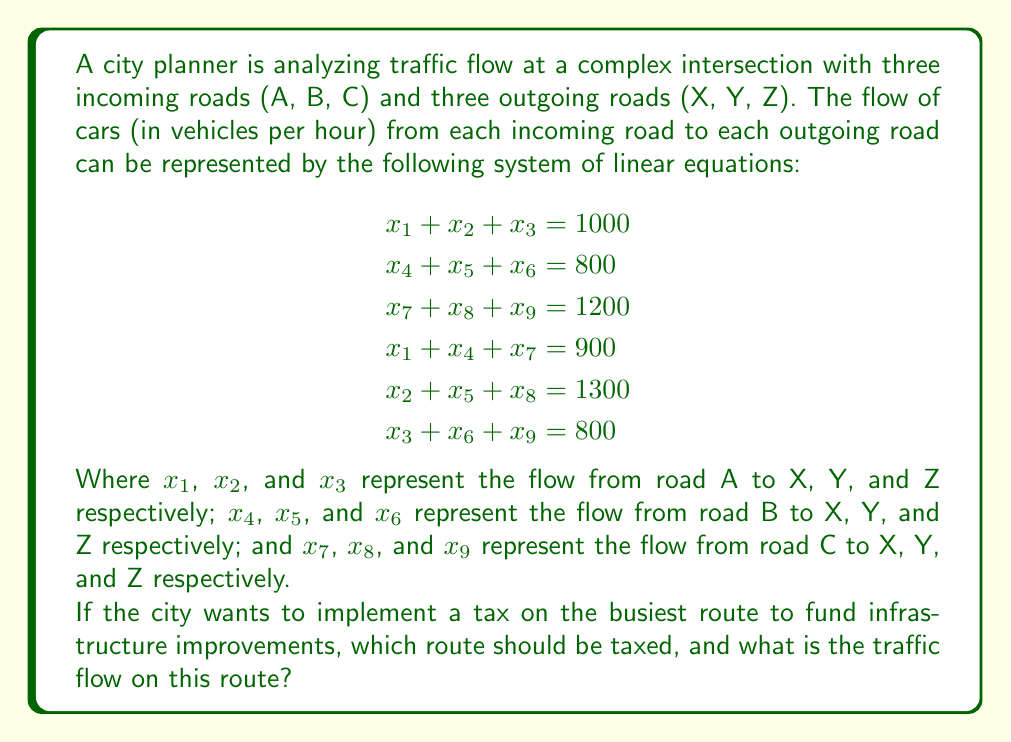What is the answer to this math problem? To solve this problem, we need to determine the traffic flow for each route and identify the busiest one. Let's approach this step-by-step:

1) First, we need to understand what each variable represents:
   $x_1$: A to X, $x_2$: A to Y, $x_3$: A to Z
   $x_4$: B to X, $x_5$: B to Y, $x_6$: B to Z
   $x_7$: C to X, $x_8$: C to Y, $x_9$: C to Z

2) We don't need to solve the entire system of equations. We can deduce the busiest route by looking at the total inflow and outflow for each road.

3) From the equations, we can see:
   Road A total outflow: 1000 vehicles/hour
   Road B total outflow: 800 vehicles/hour
   Road C total outflow: 1200 vehicles/hour
   Road X total inflow: 900 vehicles/hour
   Road Y total inflow: 1300 vehicles/hour
   Road Z total inflow: 800 vehicles/hour

4) The busiest route will be the one with the highest flow, which is the route to Road Y with 1300 vehicles/hour.

5) To determine which incoming road contributes most to this route, we need to compare $x_2$, $x_5$, and $x_8$.

6) Given the total flows, it's likely that $x_8$ (from C to Y) is the largest, as C has the highest outflow and Y has the highest inflow.

Therefore, the busiest route is from Road C to Road Y, with a flow of $x_8$ vehicles per hour. While we can't determine the exact value of $x_8$ without solving the entire system, we know it's the largest individual flow and is part of the 1300 vehicles/hour flowing into Road Y.
Answer: Route C to Y, with flow $\leq 1300$ vehicles/hour 